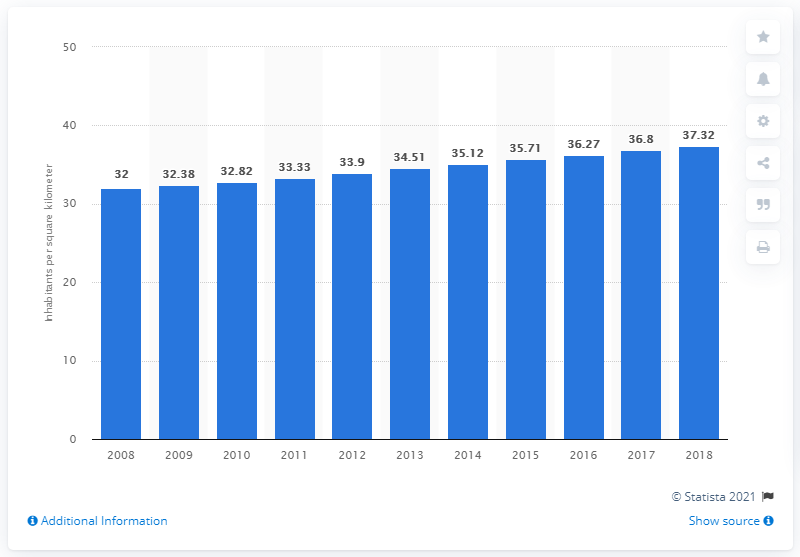Highlight a few significant elements in this photo. In 2018, Zimbabwe's population density was estimated to be 37.32 people per square kilometer. 